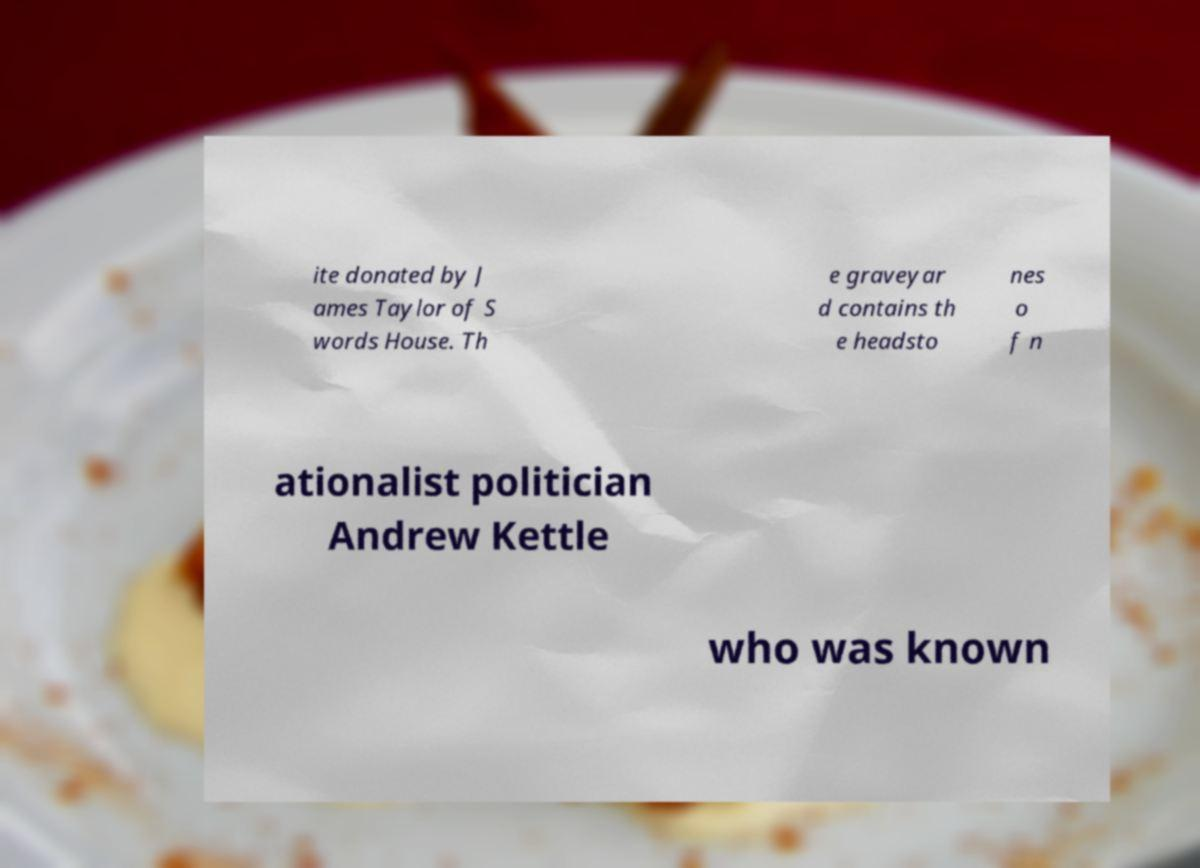Could you extract and type out the text from this image? ite donated by J ames Taylor of S words House. Th e graveyar d contains th e headsto nes o f n ationalist politician Andrew Kettle who was known 